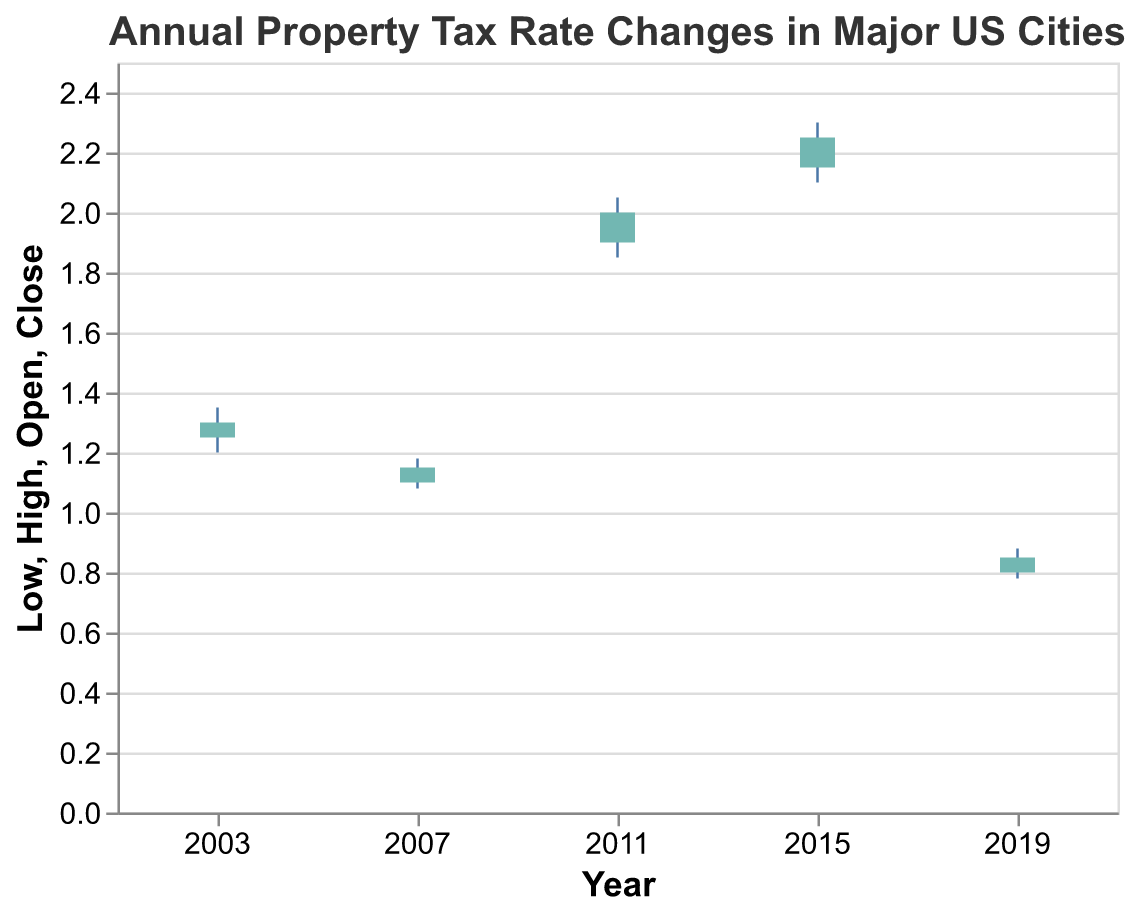How many cities are represented in the figure? Each city's property tax rate changes are represented by OHLC bars. Counting the number of cities in the dataset gives a total of five cities: New York City, Los Angeles, Chicago, Houston, and Phoenix.
Answer: Five Which city had the highest closing property tax rate? The close field in the OHLC chart represents the final property tax rate for each city. By inspecting the closing values, we see that Houston had the highest closing rate (2.25).
Answer: Houston In which year did New York City have its property tax rate data represented? Examining the 'Year' and 'City' fields, New York City's property tax rate is represented for the year 2003.
Answer: 2003 What is the difference between the high and low property tax rates for Houston? The high rate for Houston is 2.30, and the low rate is 2.10. The difference is calculated as 2.30 - 2.10 = 0.20.
Answer: 0.20 Which city shows the largest increase in property tax rate from open to close? The largest increase can be found by subtracting the 'Open' value from the 'Close' value for each city and comparing them. Chicago had an increase from 1.90 to 2.00, resulting in an increase of 0.10. New York City had an increase of 0.05; Los Angeles had an increase of 0.05; Houston had an increase of 0.10; Phoenix had an increase of 0.05. Houston has an increase from 2.15 to 2.25, resulting in an increase of 0.10.
Answer: Houston Compare the high property tax rates between Phoenix and Los Angeles. Which city has a higher rate? Inspecting the high rates, Phoenix has a high of 0.88, while Los Angeles has a high of 1.18. Therefore, Los Angeles has a higher high rate.
Answer: Los Angeles What is the average closing property tax rate of all cities represented? The closing rates for the cities are: New York City (1.30), Los Angeles (1.15), Chicago (2.00), Houston (2.25), Phoenix (0.85). To find the average, sum these rates: 1.30 + 1.15 + 2.00 + 2.25 + 0.85 = 7.55, and then divide by the number of cities, 5: 7.55 / 5 = 1.51.
Answer: 1.51 Which year had the lowest starting property tax rate? Examining the 'Open' values for each year, Phoenix in 2019 had the lowest starting rate at 0.80.
Answer: 2019 